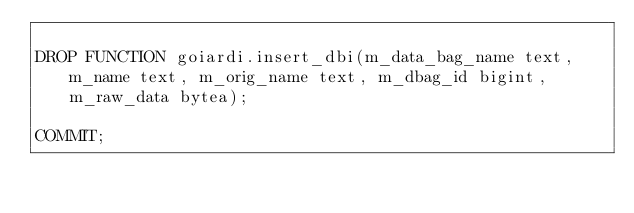Convert code to text. <code><loc_0><loc_0><loc_500><loc_500><_SQL_>
DROP FUNCTION goiardi.insert_dbi(m_data_bag_name text, m_name text, m_orig_name text, m_dbag_id bigint, m_raw_data bytea);

COMMIT;
</code> 